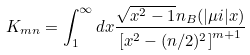<formula> <loc_0><loc_0><loc_500><loc_500>K _ { m n } = \int _ { 1 } ^ { \infty } d x \frac { \sqrt { x ^ { 2 } - 1 } n _ { B } ( | \mu i | x ) } { \left [ x ^ { 2 } - ( n / 2 ) ^ { 2 } \right ] ^ { m + 1 } }</formula> 